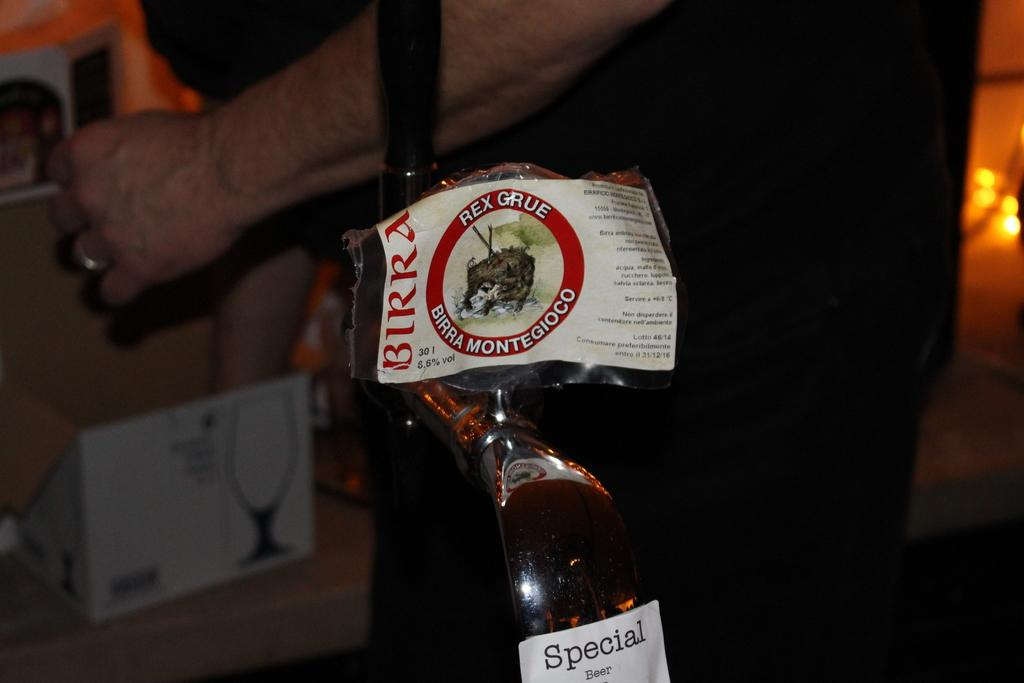<image>
Write a terse but informative summary of the picture. A person is standing behind a tap that has a while label that says Special Beer. 